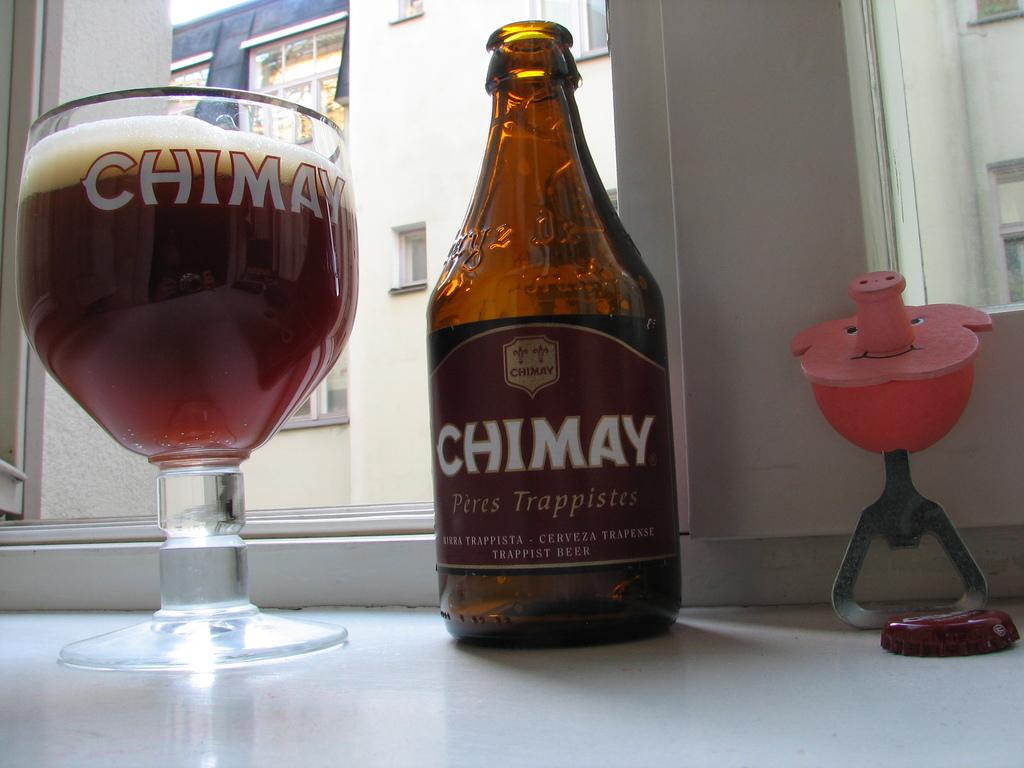Which brewery made this drink?
Keep it short and to the point. Chimay. What kind of brew is this beer?
Offer a terse response. Chimay. 